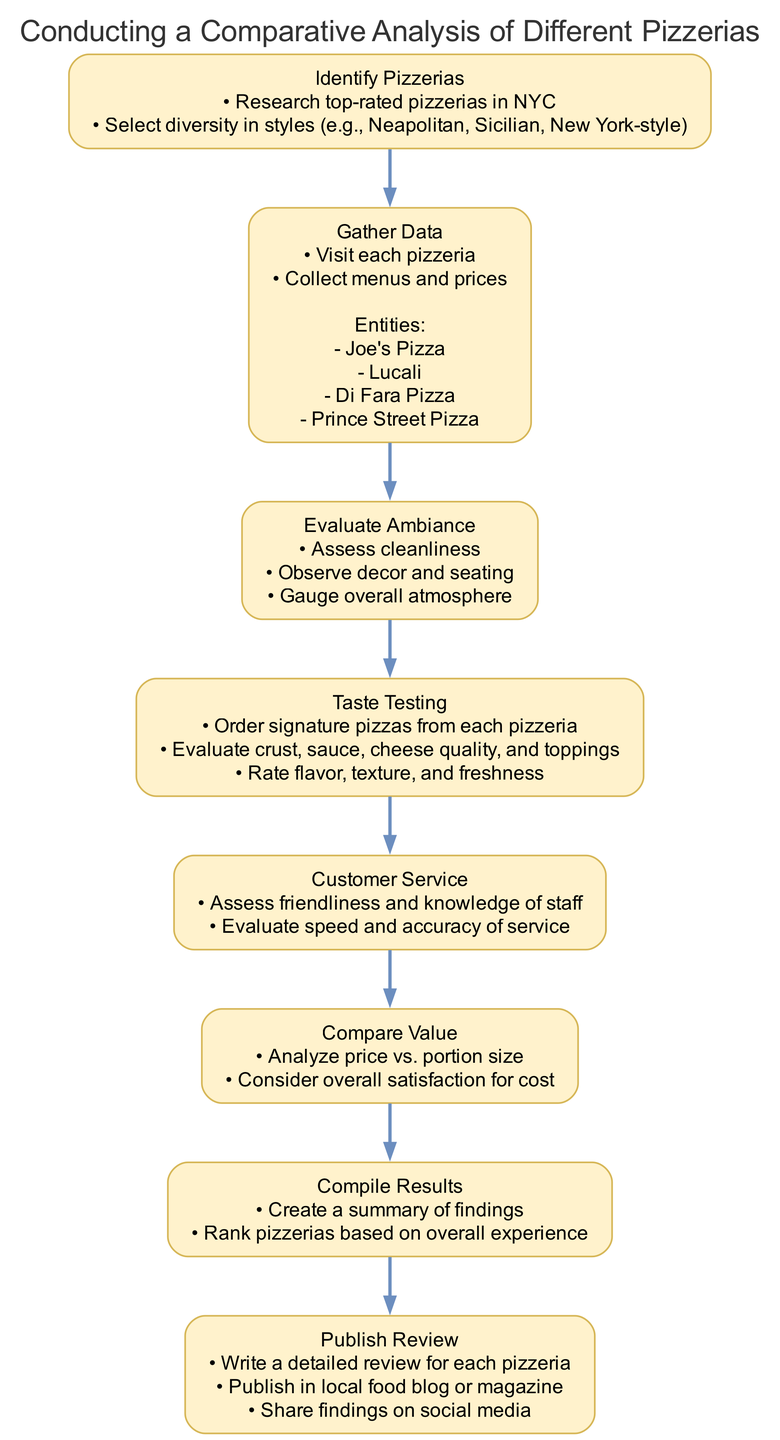What is the first step in the analysis? The first step listed in the diagram is "Identify Pizzerias". I determine this by looking at the first node in the flow chart.
Answer: Identify Pizzerias How many steps are there in total? By counting all the steps listed in the diagram, I find that there are eight distinct steps in the flow chart.
Answer: 8 Which step involves assessing the staff? The step that involves assessing the staff is "Customer Service". I identify this by looking for the step that mentions the friendliness and knowledge of the staff.
Answer: Customer Service What is the main focus of the "Taste Testing" step? The main focus of the "Taste Testing" step is to evaluate pizzas specifically on crust, sauce, cheese quality, and toppings, as stated in that step's details.
Answer: Evaluate signature pizzas What is the last step in the process? The last step in the flow chart is "Publish Review". I arrive at this answer by examining the final node connected in the sequence.
Answer: Publish Review Which step comes before "Compile Results"? The step that comes immediately before "Compile Results" is "Compare Value". This information is obtained from the direct connection in the flow chart leading to the next step.
Answer: Compare Value How many entities are listed under "Gather Data"? There are four entities listed under "Gather Data". I find this by counting each entity mentioned in the node detailing this step.
Answer: 4 In which step is ambiance assessed? The step where ambiance is assessed is "Evaluate Ambiance". I find this by searching for the step that lists elements related to atmosphere and decor.
Answer: Evaluate Ambiance What is the purpose of the "Compile Results" step? The purpose of the "Compile Results" step is to create a summary of findings and rank the pizzerias based on overall experience, as outlined in that step’s details.
Answer: Create a summary of findings 